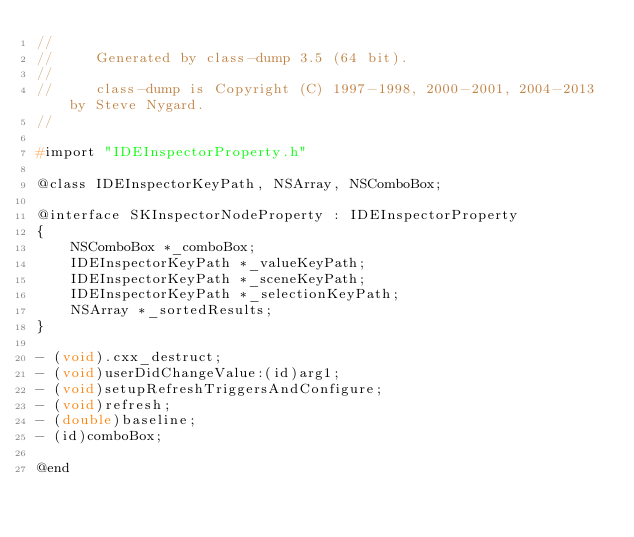<code> <loc_0><loc_0><loc_500><loc_500><_C_>//
//     Generated by class-dump 3.5 (64 bit).
//
//     class-dump is Copyright (C) 1997-1998, 2000-2001, 2004-2013 by Steve Nygard.
//

#import "IDEInspectorProperty.h"

@class IDEInspectorKeyPath, NSArray, NSComboBox;

@interface SKInspectorNodeProperty : IDEInspectorProperty
{
    NSComboBox *_comboBox;
    IDEInspectorKeyPath *_valueKeyPath;
    IDEInspectorKeyPath *_sceneKeyPath;
    IDEInspectorKeyPath *_selectionKeyPath;
    NSArray *_sortedResults;
}

- (void).cxx_destruct;
- (void)userDidChangeValue:(id)arg1;
- (void)setupRefreshTriggersAndConfigure;
- (void)refresh;
- (double)baseline;
- (id)comboBox;

@end

</code> 